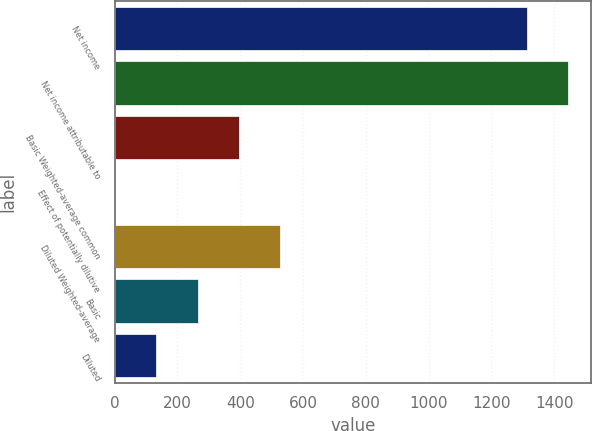Convert chart. <chart><loc_0><loc_0><loc_500><loc_500><bar_chart><fcel>Net income<fcel>Net income attributable to<fcel>Basic Weighted-average common<fcel>Effect of potentially dilutive<fcel>Diluted Weighted-average<fcel>Basic<fcel>Diluted<nl><fcel>1314<fcel>1445.21<fcel>395.53<fcel>1.9<fcel>526.74<fcel>264.32<fcel>133.11<nl></chart> 